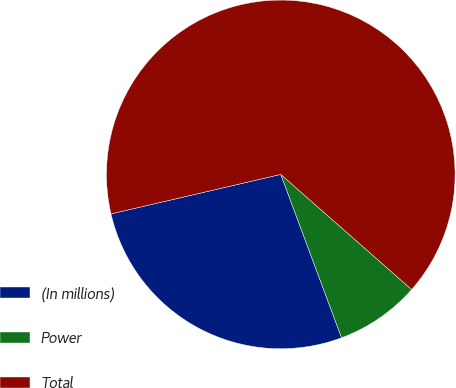Convert chart to OTSL. <chart><loc_0><loc_0><loc_500><loc_500><pie_chart><fcel>(In millions)<fcel>Power<fcel>Total<nl><fcel>27.03%<fcel>7.85%<fcel>65.12%<nl></chart> 